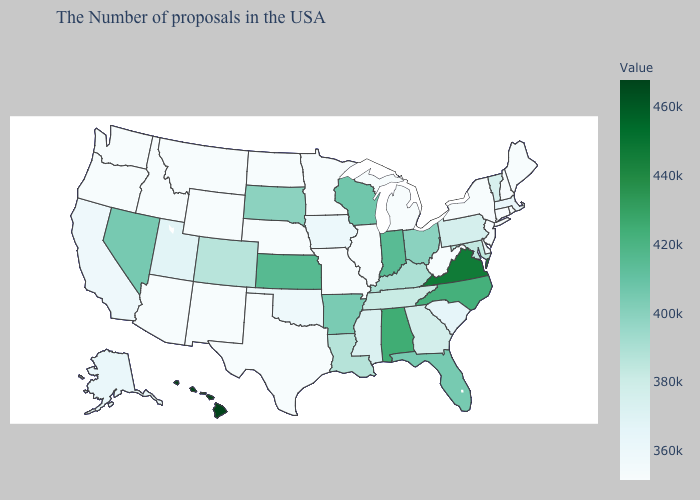Does Pennsylvania have the highest value in the Northeast?
Write a very short answer. Yes. Which states hav the highest value in the West?
Answer briefly. Hawaii. Among the states that border Idaho , does Utah have the lowest value?
Be succinct. No. Does Hawaii have the highest value in the USA?
Short answer required. Yes. Among the states that border Wisconsin , which have the highest value?
Quick response, please. Iowa. Which states have the highest value in the USA?
Give a very brief answer. Hawaii. Among the states that border Idaho , does Nevada have the highest value?
Be succinct. Yes. Does the map have missing data?
Be succinct. No. 